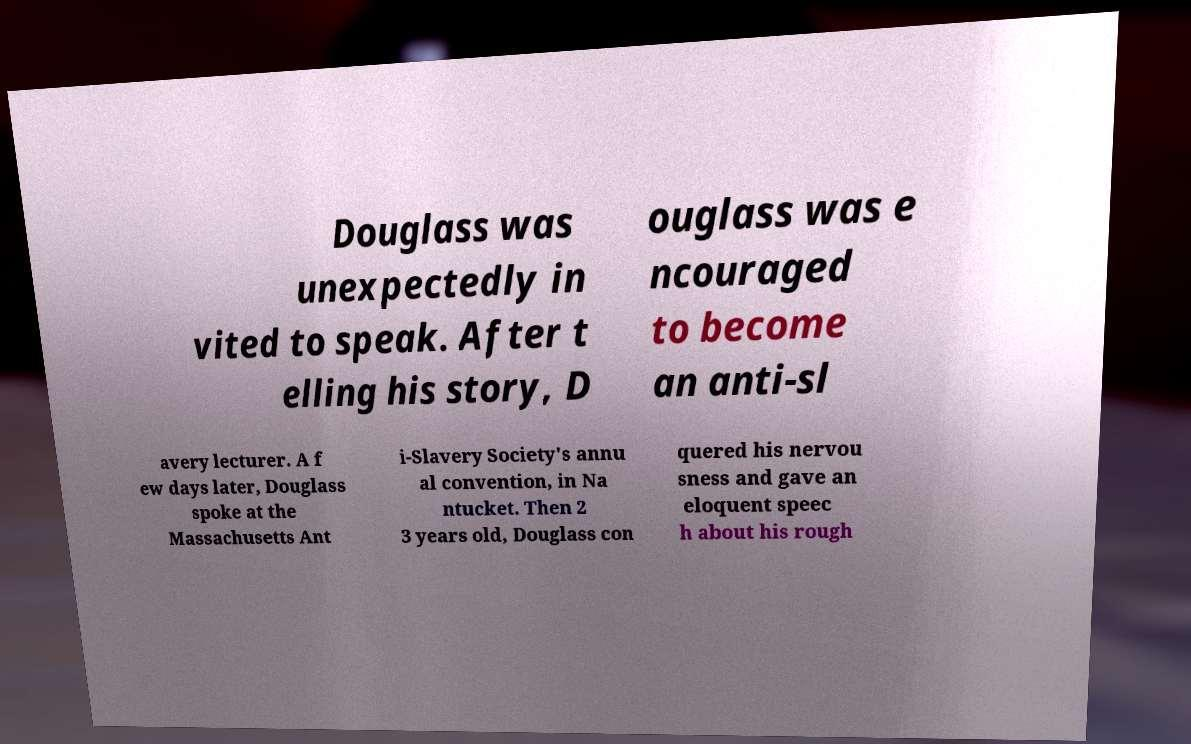There's text embedded in this image that I need extracted. Can you transcribe it verbatim? Douglass was unexpectedly in vited to speak. After t elling his story, D ouglass was e ncouraged to become an anti-sl avery lecturer. A f ew days later, Douglass spoke at the Massachusetts Ant i-Slavery Society's annu al convention, in Na ntucket. Then 2 3 years old, Douglass con quered his nervou sness and gave an eloquent speec h about his rough 